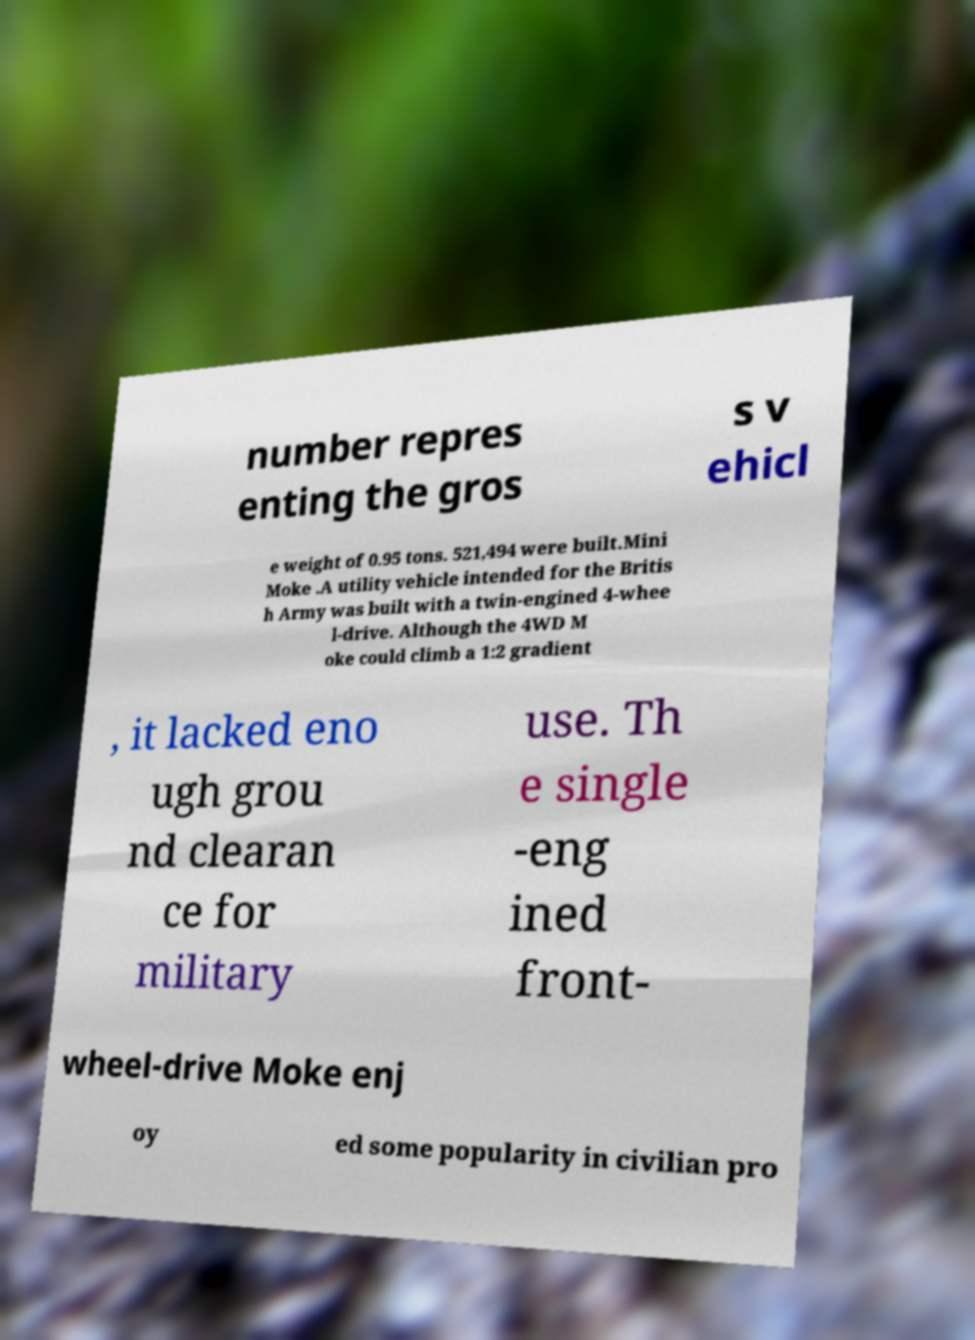Could you extract and type out the text from this image? number repres enting the gros s v ehicl e weight of 0.95 tons. 521,494 were built.Mini Moke .A utility vehicle intended for the Britis h Army was built with a twin-engined 4-whee l-drive. Although the 4WD M oke could climb a 1:2 gradient , it lacked eno ugh grou nd clearan ce for military use. Th e single -eng ined front- wheel-drive Moke enj oy ed some popularity in civilian pro 